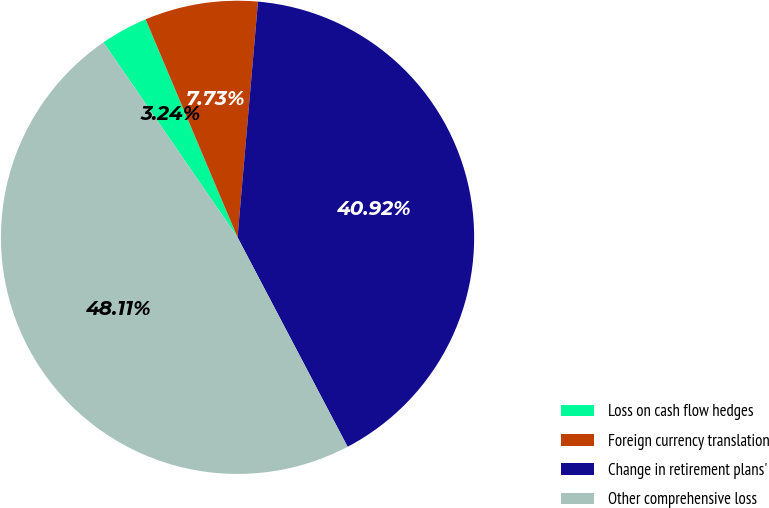<chart> <loc_0><loc_0><loc_500><loc_500><pie_chart><fcel>Loss on cash flow hedges<fcel>Foreign currency translation<fcel>Change in retirement plans'<fcel>Other comprehensive loss<nl><fcel>3.24%<fcel>7.73%<fcel>40.92%<fcel>48.11%<nl></chart> 